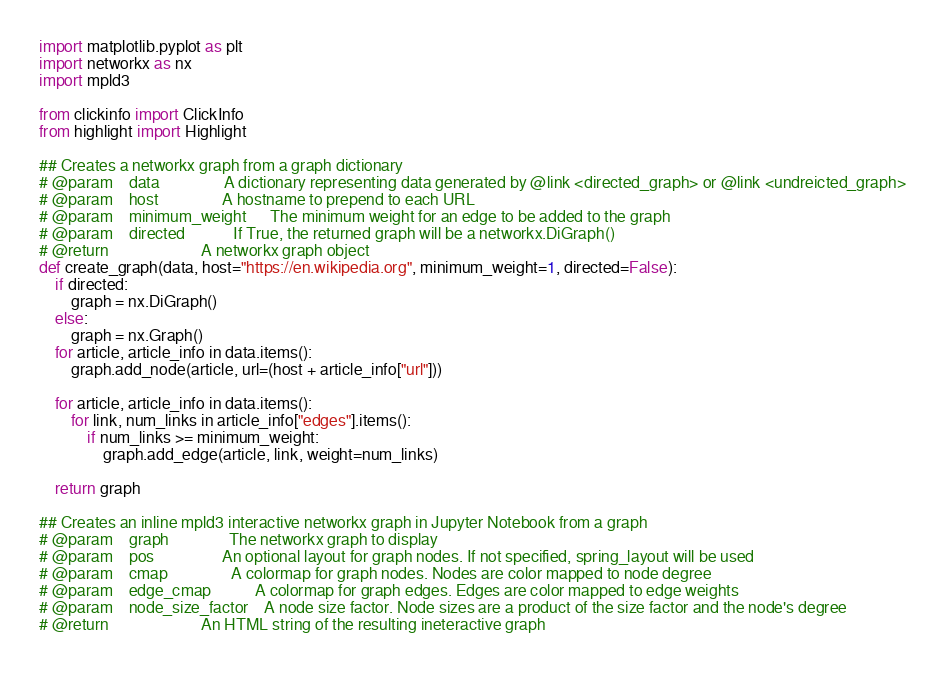<code> <loc_0><loc_0><loc_500><loc_500><_Python_>import matplotlib.pyplot as plt
import networkx as nx
import mpld3

from clickinfo import ClickInfo
from highlight import Highlight

## Creates a networkx graph from a graph dictionary
# @param	data 				A dictionary representing data generated by @link <directed_graph> or @link <undreicted_graph>
# @param	host 				A hostname to prepend to each URL
# @param	minimum_weight		The minimum weight for an edge to be added to the graph
# @param    directed            If True, the returned graph will be a networkx.DiGraph()
# @return						A networkx graph object
def create_graph(data, host="https://en.wikipedia.org", minimum_weight=1, directed=False):
	if directed:
		graph = nx.DiGraph()
	else:
		graph = nx.Graph()
	for article, article_info in data.items():
		graph.add_node(article, url=(host + article_info["url"]))

	for article, article_info in data.items():
		for link, num_links in article_info["edges"].items():
			if num_links >= minimum_weight:
				graph.add_edge(article, link, weight=num_links)

	return graph

## Creates an inline mpld3 interactive networkx graph in Jupyter Notebook from a graph
# @param	graph 				The networkx graph to display
# @param	pos					An optional layout for graph nodes. If not specified, spring_layout will be used
# @param	cmap 				A colormap for graph nodes. Nodes are color mapped to node degree
# @param	edge_cmap			A colormap for graph edges. Edges are color mapped to edge weights
# @param	node_size_factor	A node size factor. Node sizes are a product of the size factor and the node's degree
# @return                       An HTML string of the resulting ineteractive graph</code> 